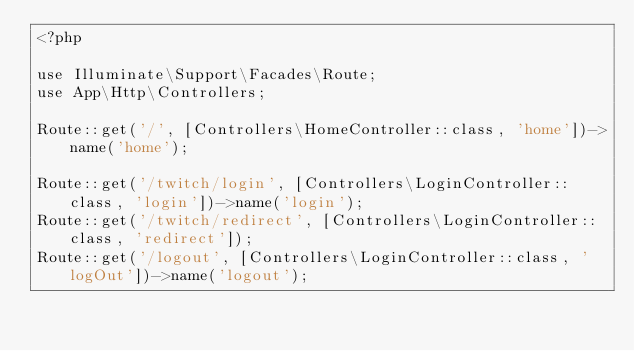Convert code to text. <code><loc_0><loc_0><loc_500><loc_500><_PHP_><?php

use Illuminate\Support\Facades\Route;
use App\Http\Controllers;

Route::get('/', [Controllers\HomeController::class, 'home'])->name('home');

Route::get('/twitch/login', [Controllers\LoginController::class, 'login'])->name('login');
Route::get('/twitch/redirect', [Controllers\LoginController::class, 'redirect']);
Route::get('/logout', [Controllers\LoginController::class, 'logOut'])->name('logout');
</code> 